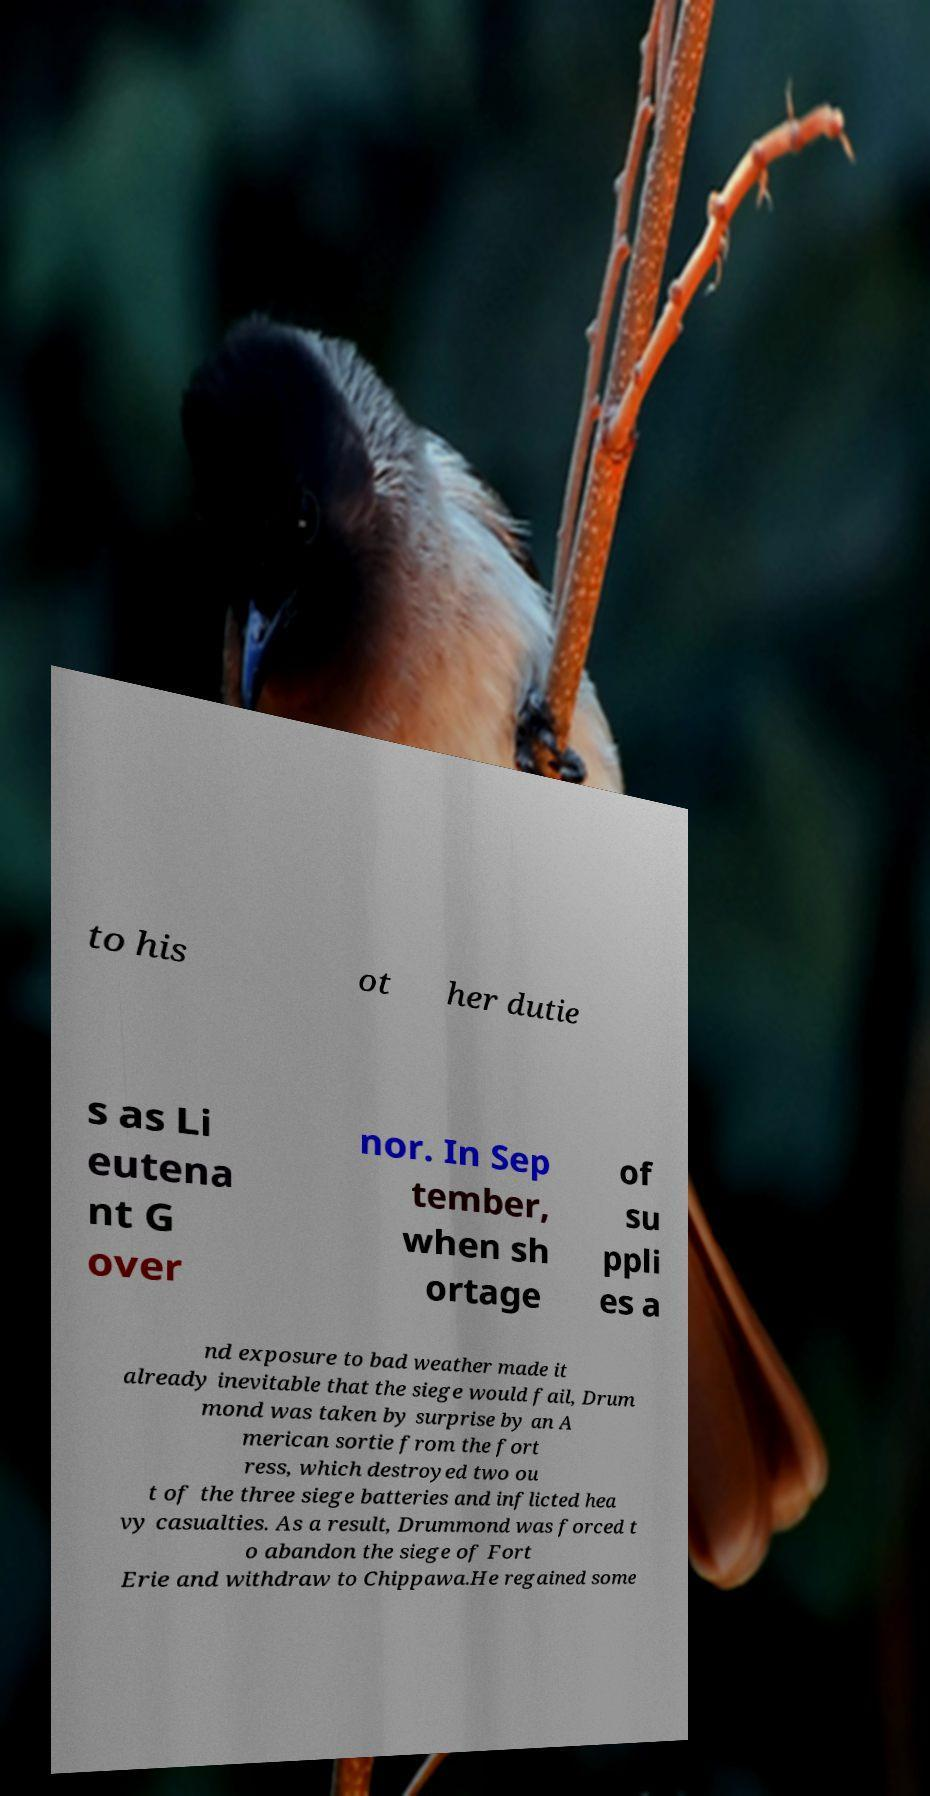I need the written content from this picture converted into text. Can you do that? to his ot her dutie s as Li eutena nt G over nor. In Sep tember, when sh ortage of su ppli es a nd exposure to bad weather made it already inevitable that the siege would fail, Drum mond was taken by surprise by an A merican sortie from the fort ress, which destroyed two ou t of the three siege batteries and inflicted hea vy casualties. As a result, Drummond was forced t o abandon the siege of Fort Erie and withdraw to Chippawa.He regained some 